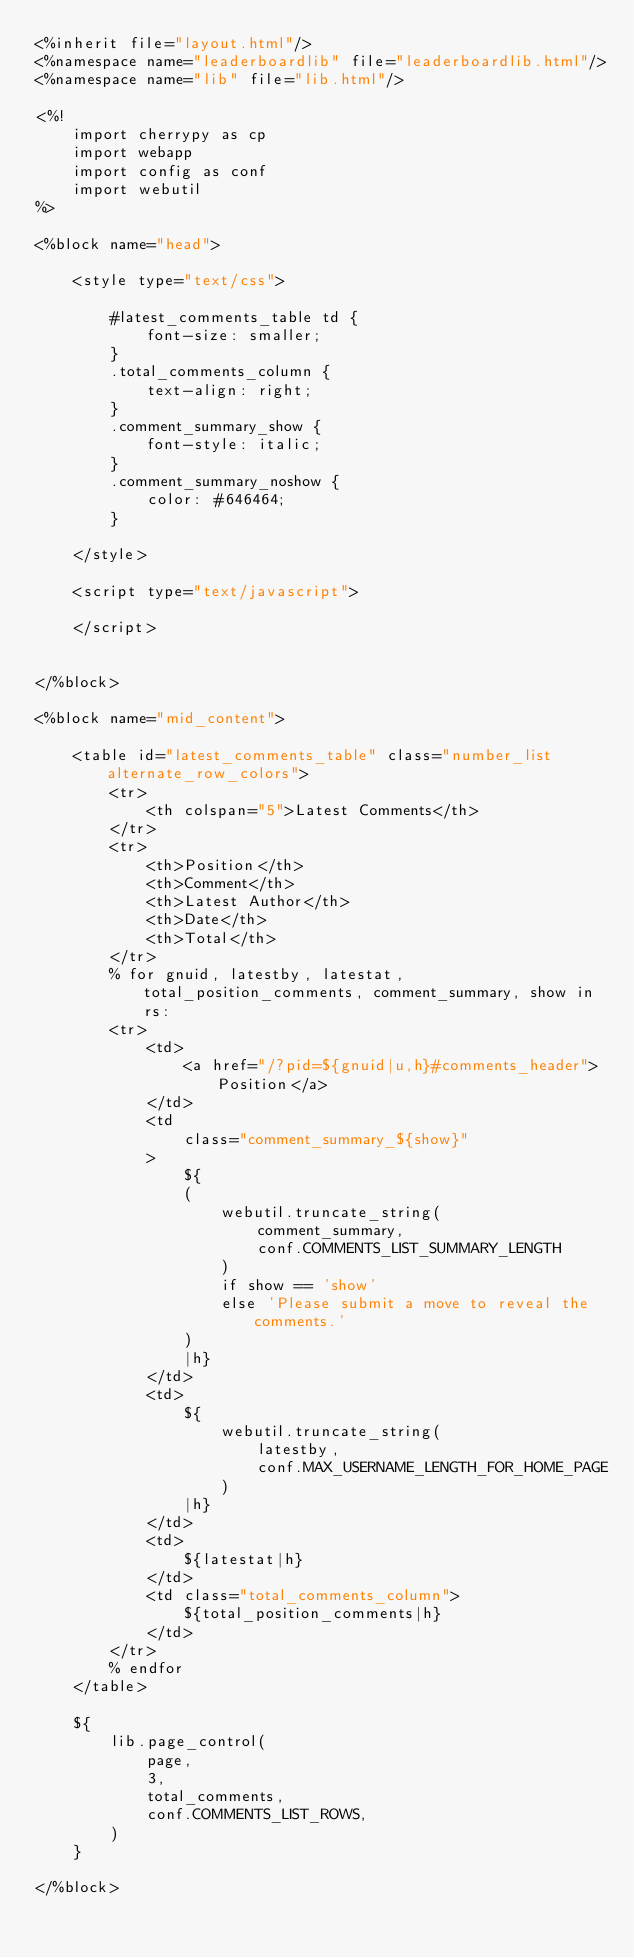<code> <loc_0><loc_0><loc_500><loc_500><_HTML_><%inherit file="layout.html"/>
<%namespace name="leaderboardlib" file="leaderboardlib.html"/>
<%namespace name="lib" file="lib.html"/>

<%!
    import cherrypy as cp
    import webapp
    import config as conf
    import webutil
%>

<%block name="head">

    <style type="text/css">

        #latest_comments_table td {
            font-size: smaller;
        }
        .total_comments_column {
            text-align: right;
        }
        .comment_summary_show {
            font-style: italic;
        }
        .comment_summary_noshow {
            color: #646464;
        }

    </style>

    <script type="text/javascript">

    </script>


</%block>

<%block name="mid_content">

    <table id="latest_comments_table" class="number_list alternate_row_colors">
        <tr>
            <th colspan="5">Latest Comments</th>
        </tr>
        <tr>
            <th>Position</th>
            <th>Comment</th>
            <th>Latest Author</th>
            <th>Date</th>
            <th>Total</th>
        </tr>
        % for gnuid, latestby, latestat, total_position_comments, comment_summary, show in rs:
        <tr>
            <td>
                <a href="/?pid=${gnuid|u,h}#comments_header">Position</a>
            </td>
            <td
                class="comment_summary_${show}"
            >
                ${
                (
                    webutil.truncate_string(
                        comment_summary, 
                        conf.COMMENTS_LIST_SUMMARY_LENGTH
                    )
                    if show == 'show'
                    else 'Please submit a move to reveal the comments.'
                )
                |h}
            </td>
            <td>
                ${
                    webutil.truncate_string(
                        latestby, 
                        conf.MAX_USERNAME_LENGTH_FOR_HOME_PAGE
                    )
                |h}
            </td>
            <td>
                ${latestat|h}
            </td>
            <td class="total_comments_column">
                ${total_position_comments|h}
            </td>
        </tr>
        % endfor
    </table>

    ${
        lib.page_control(
            page,
            3,
            total_comments,
            conf.COMMENTS_LIST_ROWS,
        )
    }

</%block>

</code> 